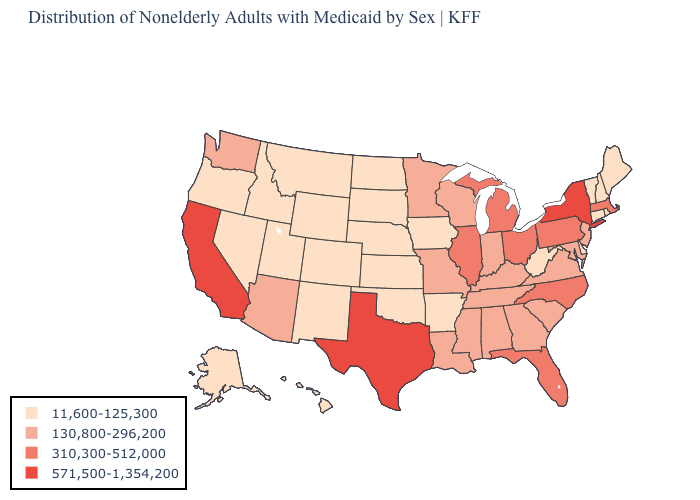What is the highest value in the USA?
Answer briefly. 571,500-1,354,200. What is the lowest value in the USA?
Quick response, please. 11,600-125,300. What is the value of Delaware?
Concise answer only. 11,600-125,300. Name the states that have a value in the range 11,600-125,300?
Give a very brief answer. Alaska, Arkansas, Colorado, Connecticut, Delaware, Hawaii, Idaho, Iowa, Kansas, Maine, Montana, Nebraska, Nevada, New Hampshire, New Mexico, North Dakota, Oklahoma, Oregon, Rhode Island, South Dakota, Utah, Vermont, West Virginia, Wyoming. Among the states that border Oklahoma , does New Mexico have the highest value?
Be succinct. No. Which states have the highest value in the USA?
Answer briefly. California, New York, Texas. What is the value of New Hampshire?
Quick response, please. 11,600-125,300. Does Minnesota have the same value as South Carolina?
Give a very brief answer. Yes. Name the states that have a value in the range 11,600-125,300?
Keep it brief. Alaska, Arkansas, Colorado, Connecticut, Delaware, Hawaii, Idaho, Iowa, Kansas, Maine, Montana, Nebraska, Nevada, New Hampshire, New Mexico, North Dakota, Oklahoma, Oregon, Rhode Island, South Dakota, Utah, Vermont, West Virginia, Wyoming. Does Illinois have the highest value in the MidWest?
Keep it brief. Yes. Which states have the highest value in the USA?
Give a very brief answer. California, New York, Texas. What is the value of Washington?
Be succinct. 130,800-296,200. What is the highest value in states that border Rhode Island?
Write a very short answer. 310,300-512,000. What is the value of Tennessee?
Keep it brief. 130,800-296,200. What is the highest value in states that border Virginia?
Concise answer only. 310,300-512,000. 